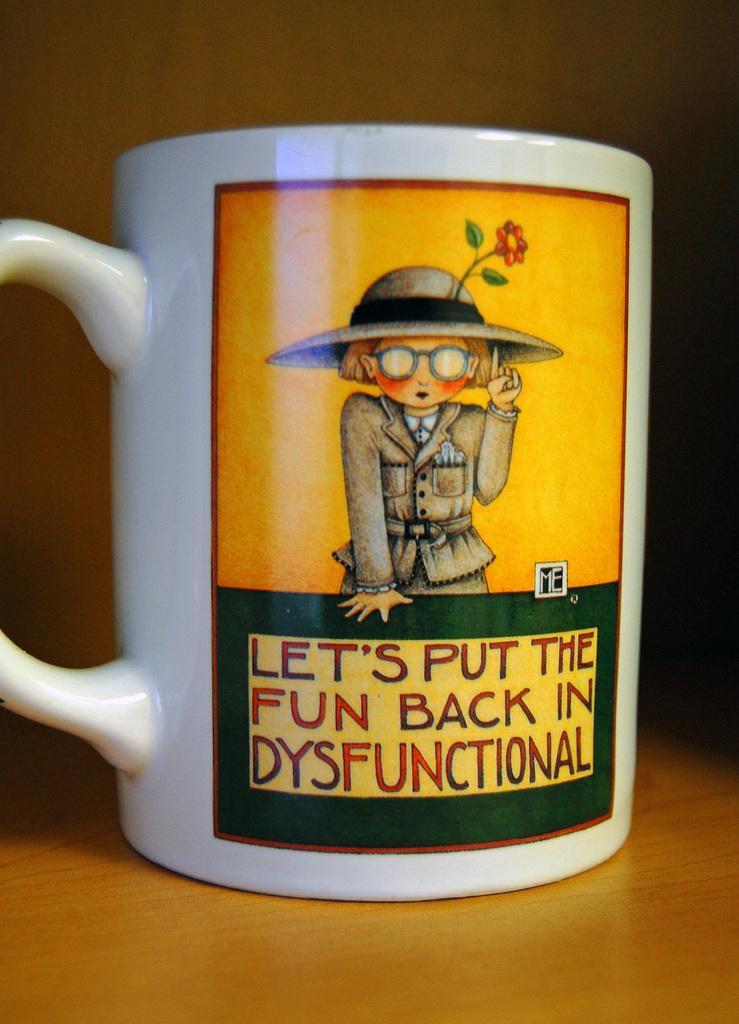Describe this image in one or two sentences. In this image there is a cup on the table, on the cup there is a picture of a person, a flower and some text. 